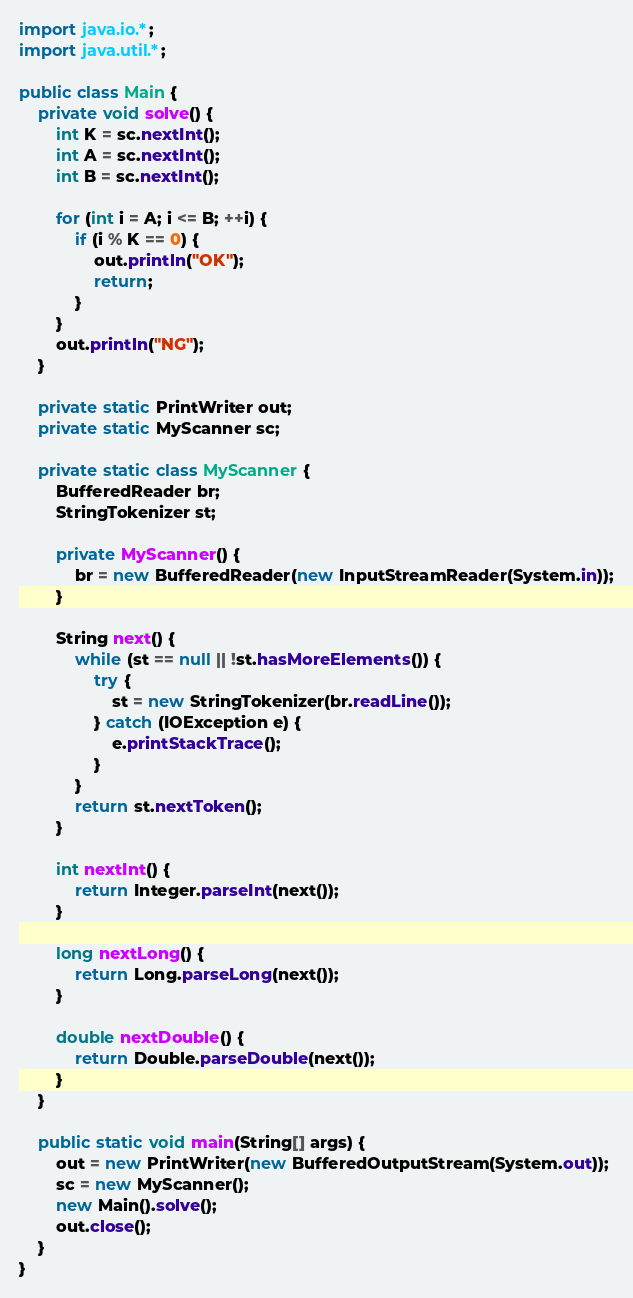Convert code to text. <code><loc_0><loc_0><loc_500><loc_500><_Java_>
import java.io.*;
import java.util.*;

public class Main {
    private void solve() {
        int K = sc.nextInt();
        int A = sc.nextInt();
        int B = sc.nextInt();

        for (int i = A; i <= B; ++i) {
            if (i % K == 0) {
                out.println("OK");
                return;
            }
        }
        out.println("NG");
    }

    private static PrintWriter out;
    private static MyScanner sc;

    private static class MyScanner {
        BufferedReader br;
        StringTokenizer st;

        private MyScanner() {
            br = new BufferedReader(new InputStreamReader(System.in));
        }

        String next() {
            while (st == null || !st.hasMoreElements()) {
                try {
                    st = new StringTokenizer(br.readLine());
                } catch (IOException e) {
                    e.printStackTrace();
                }
            }
            return st.nextToken();
        }

        int nextInt() {
            return Integer.parseInt(next());
        }

        long nextLong() {
            return Long.parseLong(next());
        }

        double nextDouble() {
            return Double.parseDouble(next());
        }
    }

    public static void main(String[] args) {
        out = new PrintWriter(new BufferedOutputStream(System.out));
        sc = new MyScanner();
        new Main().solve();
        out.close();
    }
}
</code> 